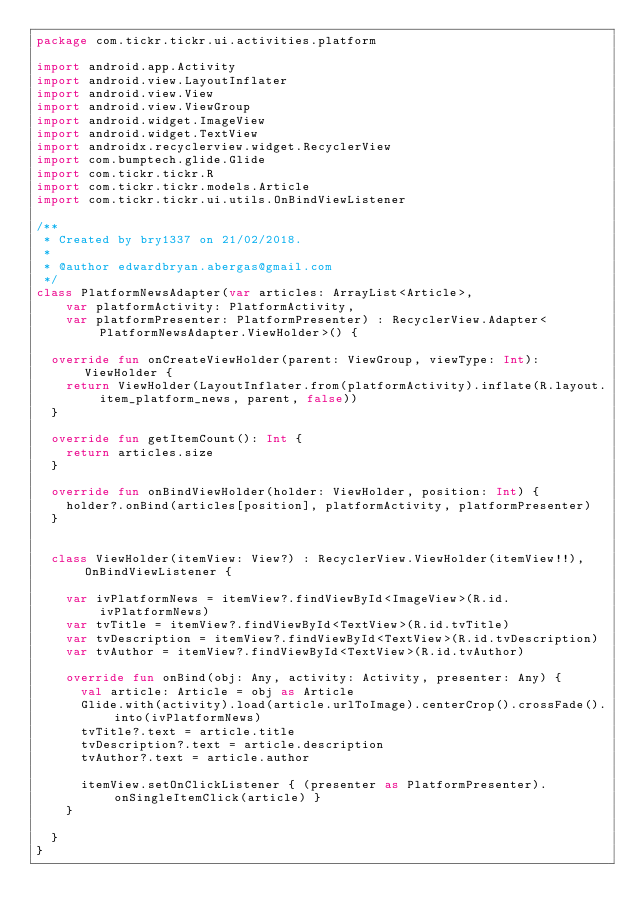Convert code to text. <code><loc_0><loc_0><loc_500><loc_500><_Kotlin_>package com.tickr.tickr.ui.activities.platform

import android.app.Activity
import android.view.LayoutInflater
import android.view.View
import android.view.ViewGroup
import android.widget.ImageView
import android.widget.TextView
import androidx.recyclerview.widget.RecyclerView
import com.bumptech.glide.Glide
import com.tickr.tickr.R
import com.tickr.tickr.models.Article
import com.tickr.tickr.ui.utils.OnBindViewListener

/**
 * Created by bry1337 on 21/02/2018.
 *
 * @author edwardbryan.abergas@gmail.com
 */
class PlatformNewsAdapter(var articles: ArrayList<Article>,
    var platformActivity: PlatformActivity,
    var platformPresenter: PlatformPresenter) : RecyclerView.Adapter<PlatformNewsAdapter.ViewHolder>() {

  override fun onCreateViewHolder(parent: ViewGroup, viewType: Int): ViewHolder {
    return ViewHolder(LayoutInflater.from(platformActivity).inflate(R.layout.item_platform_news, parent, false))
  }

  override fun getItemCount(): Int {
    return articles.size
  }

  override fun onBindViewHolder(holder: ViewHolder, position: Int) {
    holder?.onBind(articles[position], platformActivity, platformPresenter)
  }


  class ViewHolder(itemView: View?) : RecyclerView.ViewHolder(itemView!!), OnBindViewListener {

    var ivPlatformNews = itemView?.findViewById<ImageView>(R.id.ivPlatformNews)
    var tvTitle = itemView?.findViewById<TextView>(R.id.tvTitle)
    var tvDescription = itemView?.findViewById<TextView>(R.id.tvDescription)
    var tvAuthor = itemView?.findViewById<TextView>(R.id.tvAuthor)

    override fun onBind(obj: Any, activity: Activity, presenter: Any) {
      val article: Article = obj as Article
      Glide.with(activity).load(article.urlToImage).centerCrop().crossFade().into(ivPlatformNews)
      tvTitle?.text = article.title
      tvDescription?.text = article.description
      tvAuthor?.text = article.author

      itemView.setOnClickListener { (presenter as PlatformPresenter).onSingleItemClick(article) }
    }

  }
}</code> 